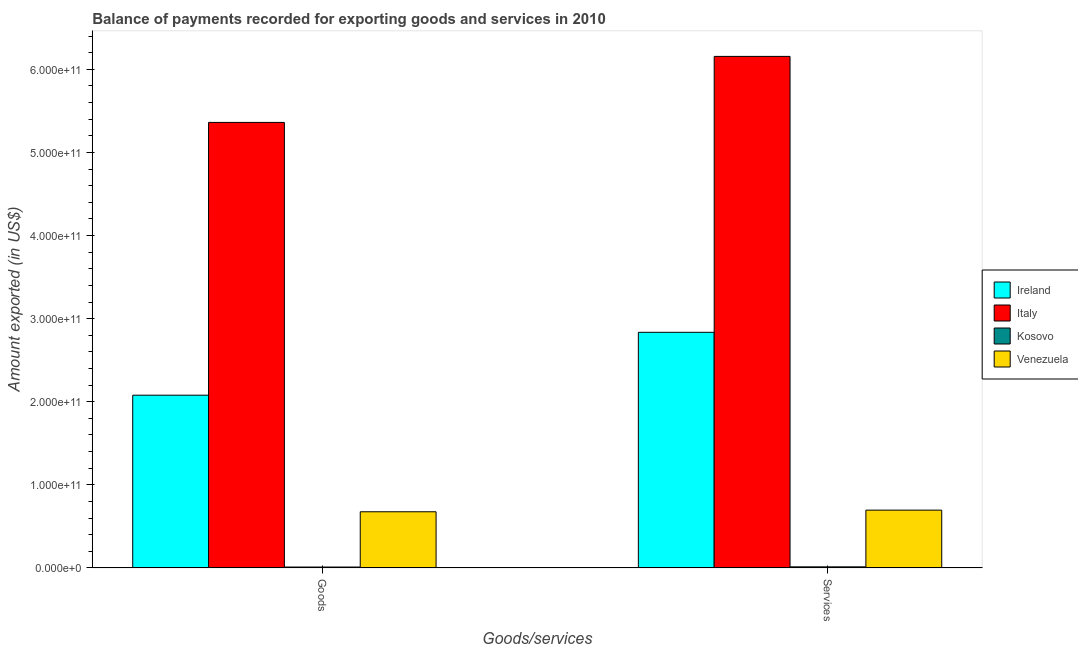How many different coloured bars are there?
Give a very brief answer. 4. How many groups of bars are there?
Ensure brevity in your answer.  2. What is the label of the 1st group of bars from the left?
Make the answer very short. Goods. What is the amount of services exported in Italy?
Your answer should be very brief. 6.16e+11. Across all countries, what is the maximum amount of goods exported?
Your answer should be very brief. 5.36e+11. Across all countries, what is the minimum amount of goods exported?
Give a very brief answer. 1.10e+09. In which country was the amount of services exported minimum?
Ensure brevity in your answer.  Kosovo. What is the total amount of services exported in the graph?
Your answer should be very brief. 9.70e+11. What is the difference between the amount of goods exported in Venezuela and that in Italy?
Ensure brevity in your answer.  -4.69e+11. What is the difference between the amount of goods exported in Kosovo and the amount of services exported in Italy?
Your response must be concise. -6.14e+11. What is the average amount of goods exported per country?
Provide a short and direct response. 2.03e+11. What is the difference between the amount of services exported and amount of goods exported in Kosovo?
Make the answer very short. 2.34e+08. What is the ratio of the amount of goods exported in Venezuela to that in Ireland?
Give a very brief answer. 0.33. Is the amount of services exported in Venezuela less than that in Italy?
Keep it short and to the point. Yes. What does the 1st bar from the left in Services represents?
Offer a terse response. Ireland. What does the 4th bar from the right in Goods represents?
Provide a succinct answer. Ireland. How many countries are there in the graph?
Offer a very short reply. 4. What is the difference between two consecutive major ticks on the Y-axis?
Your answer should be compact. 1.00e+11. Does the graph contain grids?
Your answer should be compact. No. Where does the legend appear in the graph?
Your response must be concise. Center right. How are the legend labels stacked?
Your answer should be compact. Vertical. What is the title of the graph?
Provide a short and direct response. Balance of payments recorded for exporting goods and services in 2010. What is the label or title of the X-axis?
Make the answer very short. Goods/services. What is the label or title of the Y-axis?
Provide a short and direct response. Amount exported (in US$). What is the Amount exported (in US$) in Ireland in Goods?
Provide a succinct answer. 2.08e+11. What is the Amount exported (in US$) of Italy in Goods?
Offer a terse response. 5.36e+11. What is the Amount exported (in US$) of Kosovo in Goods?
Your answer should be very brief. 1.10e+09. What is the Amount exported (in US$) of Venezuela in Goods?
Make the answer very short. 6.76e+1. What is the Amount exported (in US$) in Ireland in Services?
Make the answer very short. 2.84e+11. What is the Amount exported (in US$) of Italy in Services?
Your answer should be very brief. 6.16e+11. What is the Amount exported (in US$) in Kosovo in Services?
Make the answer very short. 1.33e+09. What is the Amount exported (in US$) in Venezuela in Services?
Provide a short and direct response. 6.96e+1. Across all Goods/services, what is the maximum Amount exported (in US$) of Ireland?
Keep it short and to the point. 2.84e+11. Across all Goods/services, what is the maximum Amount exported (in US$) of Italy?
Offer a terse response. 6.16e+11. Across all Goods/services, what is the maximum Amount exported (in US$) of Kosovo?
Make the answer very short. 1.33e+09. Across all Goods/services, what is the maximum Amount exported (in US$) in Venezuela?
Give a very brief answer. 6.96e+1. Across all Goods/services, what is the minimum Amount exported (in US$) of Ireland?
Provide a short and direct response. 2.08e+11. Across all Goods/services, what is the minimum Amount exported (in US$) of Italy?
Give a very brief answer. 5.36e+11. Across all Goods/services, what is the minimum Amount exported (in US$) in Kosovo?
Provide a short and direct response. 1.10e+09. Across all Goods/services, what is the minimum Amount exported (in US$) in Venezuela?
Keep it short and to the point. 6.76e+1. What is the total Amount exported (in US$) of Ireland in the graph?
Ensure brevity in your answer.  4.91e+11. What is the total Amount exported (in US$) of Italy in the graph?
Keep it short and to the point. 1.15e+12. What is the total Amount exported (in US$) in Kosovo in the graph?
Offer a terse response. 2.43e+09. What is the total Amount exported (in US$) in Venezuela in the graph?
Your response must be concise. 1.37e+11. What is the difference between the Amount exported (in US$) of Ireland in Goods and that in Services?
Your answer should be compact. -7.57e+1. What is the difference between the Amount exported (in US$) of Italy in Goods and that in Services?
Offer a terse response. -7.94e+1. What is the difference between the Amount exported (in US$) in Kosovo in Goods and that in Services?
Make the answer very short. -2.34e+08. What is the difference between the Amount exported (in US$) of Venezuela in Goods and that in Services?
Your response must be concise. -1.98e+09. What is the difference between the Amount exported (in US$) of Ireland in Goods and the Amount exported (in US$) of Italy in Services?
Offer a terse response. -4.08e+11. What is the difference between the Amount exported (in US$) in Ireland in Goods and the Amount exported (in US$) in Kosovo in Services?
Your answer should be compact. 2.07e+11. What is the difference between the Amount exported (in US$) in Ireland in Goods and the Amount exported (in US$) in Venezuela in Services?
Provide a succinct answer. 1.38e+11. What is the difference between the Amount exported (in US$) of Italy in Goods and the Amount exported (in US$) of Kosovo in Services?
Your answer should be very brief. 5.35e+11. What is the difference between the Amount exported (in US$) in Italy in Goods and the Amount exported (in US$) in Venezuela in Services?
Provide a short and direct response. 4.67e+11. What is the difference between the Amount exported (in US$) in Kosovo in Goods and the Amount exported (in US$) in Venezuela in Services?
Your response must be concise. -6.85e+1. What is the average Amount exported (in US$) in Ireland per Goods/services?
Offer a terse response. 2.46e+11. What is the average Amount exported (in US$) of Italy per Goods/services?
Make the answer very short. 5.76e+11. What is the average Amount exported (in US$) in Kosovo per Goods/services?
Give a very brief answer. 1.22e+09. What is the average Amount exported (in US$) in Venezuela per Goods/services?
Your answer should be very brief. 6.86e+1. What is the difference between the Amount exported (in US$) of Ireland and Amount exported (in US$) of Italy in Goods?
Your answer should be very brief. -3.28e+11. What is the difference between the Amount exported (in US$) of Ireland and Amount exported (in US$) of Kosovo in Goods?
Your response must be concise. 2.07e+11. What is the difference between the Amount exported (in US$) of Ireland and Amount exported (in US$) of Venezuela in Goods?
Provide a short and direct response. 1.40e+11. What is the difference between the Amount exported (in US$) of Italy and Amount exported (in US$) of Kosovo in Goods?
Give a very brief answer. 5.35e+11. What is the difference between the Amount exported (in US$) in Italy and Amount exported (in US$) in Venezuela in Goods?
Provide a short and direct response. 4.69e+11. What is the difference between the Amount exported (in US$) in Kosovo and Amount exported (in US$) in Venezuela in Goods?
Your answer should be very brief. -6.65e+1. What is the difference between the Amount exported (in US$) in Ireland and Amount exported (in US$) in Italy in Services?
Provide a short and direct response. -3.32e+11. What is the difference between the Amount exported (in US$) in Ireland and Amount exported (in US$) in Kosovo in Services?
Your answer should be very brief. 2.82e+11. What is the difference between the Amount exported (in US$) in Ireland and Amount exported (in US$) in Venezuela in Services?
Offer a terse response. 2.14e+11. What is the difference between the Amount exported (in US$) in Italy and Amount exported (in US$) in Kosovo in Services?
Make the answer very short. 6.14e+11. What is the difference between the Amount exported (in US$) in Italy and Amount exported (in US$) in Venezuela in Services?
Your response must be concise. 5.46e+11. What is the difference between the Amount exported (in US$) of Kosovo and Amount exported (in US$) of Venezuela in Services?
Ensure brevity in your answer.  -6.83e+1. What is the ratio of the Amount exported (in US$) in Ireland in Goods to that in Services?
Provide a succinct answer. 0.73. What is the ratio of the Amount exported (in US$) of Italy in Goods to that in Services?
Offer a terse response. 0.87. What is the ratio of the Amount exported (in US$) in Kosovo in Goods to that in Services?
Make the answer very short. 0.82. What is the ratio of the Amount exported (in US$) in Venezuela in Goods to that in Services?
Ensure brevity in your answer.  0.97. What is the difference between the highest and the second highest Amount exported (in US$) of Ireland?
Offer a very short reply. 7.57e+1. What is the difference between the highest and the second highest Amount exported (in US$) in Italy?
Ensure brevity in your answer.  7.94e+1. What is the difference between the highest and the second highest Amount exported (in US$) in Kosovo?
Give a very brief answer. 2.34e+08. What is the difference between the highest and the second highest Amount exported (in US$) in Venezuela?
Your response must be concise. 1.98e+09. What is the difference between the highest and the lowest Amount exported (in US$) in Ireland?
Keep it short and to the point. 7.57e+1. What is the difference between the highest and the lowest Amount exported (in US$) in Italy?
Your response must be concise. 7.94e+1. What is the difference between the highest and the lowest Amount exported (in US$) of Kosovo?
Offer a very short reply. 2.34e+08. What is the difference between the highest and the lowest Amount exported (in US$) of Venezuela?
Provide a short and direct response. 1.98e+09. 